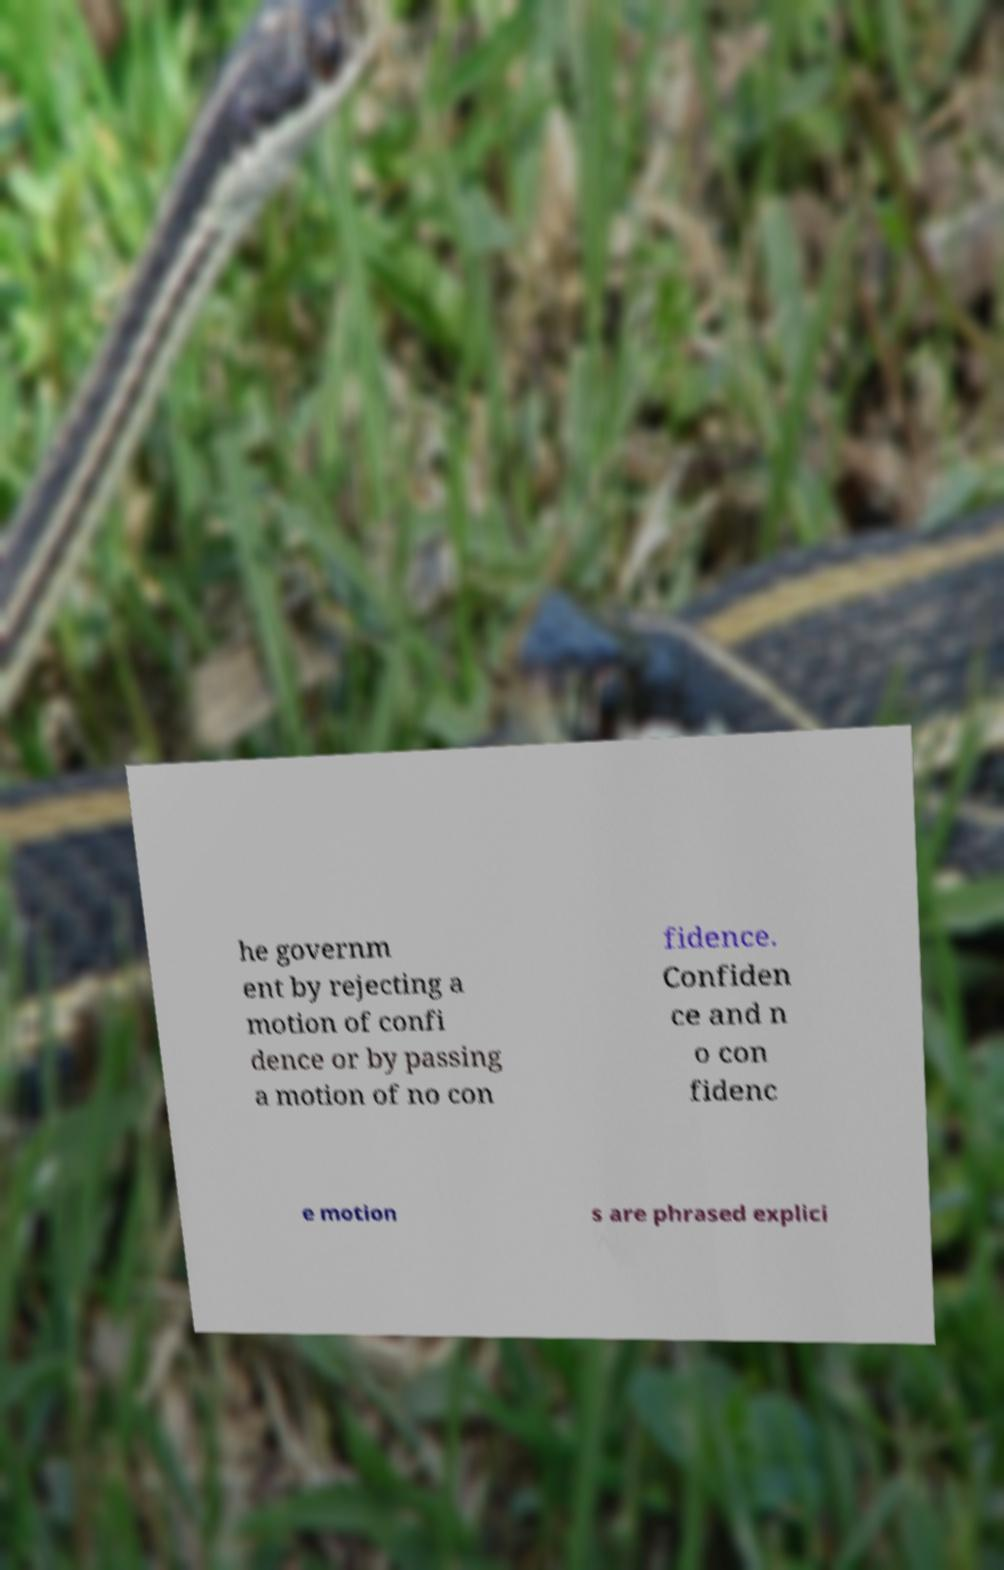Please read and relay the text visible in this image. What does it say? he governm ent by rejecting a motion of confi dence or by passing a motion of no con fidence. Confiden ce and n o con fidenc e motion s are phrased explici 